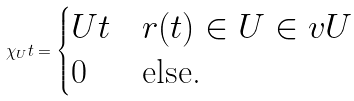<formula> <loc_0><loc_0><loc_500><loc_500>\chi _ { U } t = \begin{cases} U t & r ( t ) \in U \in v U \\ 0 & \text {else.} \end{cases}</formula> 